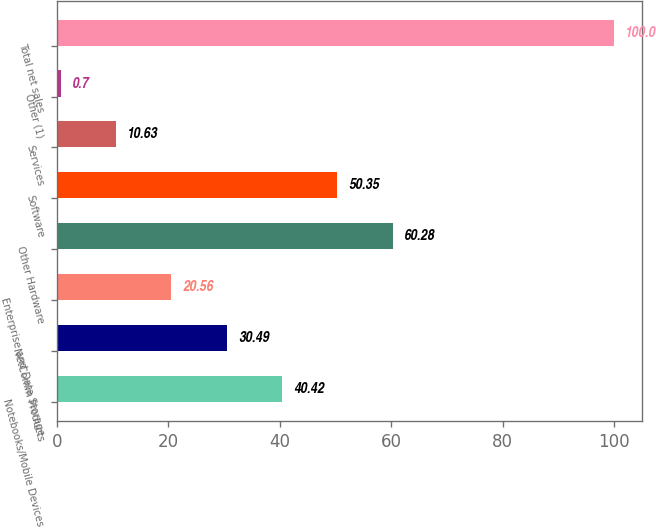Convert chart to OTSL. <chart><loc_0><loc_0><loc_500><loc_500><bar_chart><fcel>Notebooks/Mobile Devices<fcel>NetComm Products<fcel>Enterprise and Data Storage<fcel>Other Hardware<fcel>Software<fcel>Services<fcel>Other (1)<fcel>Total net sales<nl><fcel>40.42<fcel>30.49<fcel>20.56<fcel>60.28<fcel>50.35<fcel>10.63<fcel>0.7<fcel>100<nl></chart> 